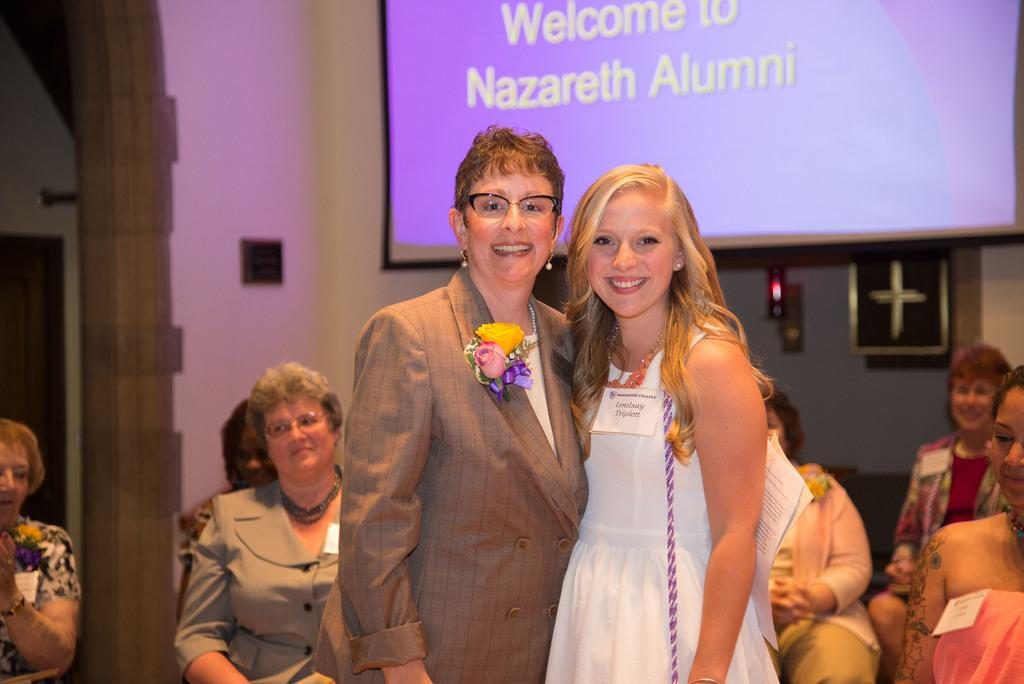How many people are standing and smiling in the image? There are two persons standing and smiling in the image. What are the other people in the image doing? There is a group of people sitting in the image. What can be seen in the background of the image? Walls are visible in the image. What is the purpose of the projector screen in the image? The projector screen is likely used for presentations or displaying visuals. What type of soda is being served at the event in the image? There is no indication of any soda being served in the image. Can you tell me how many skateboards are visible in the image? There are no skateboards present in the image. 